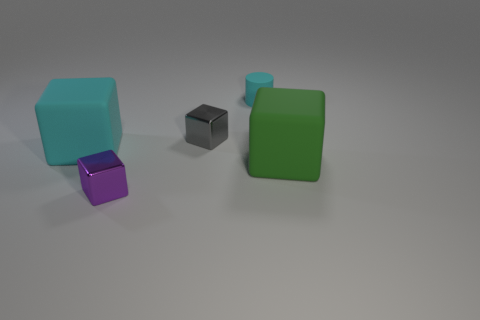Subtract all purple cubes. How many cubes are left? 3 Subtract all green cubes. How many cubes are left? 3 Subtract 1 blocks. How many blocks are left? 3 Add 2 large purple matte spheres. How many objects exist? 7 Subtract all brown cubes. Subtract all yellow cylinders. How many cubes are left? 4 Subtract all blocks. How many objects are left? 1 Subtract 1 green blocks. How many objects are left? 4 Subtract all purple shiny cubes. Subtract all tiny gray objects. How many objects are left? 3 Add 3 cylinders. How many cylinders are left? 4 Add 4 blue matte spheres. How many blue matte spheres exist? 4 